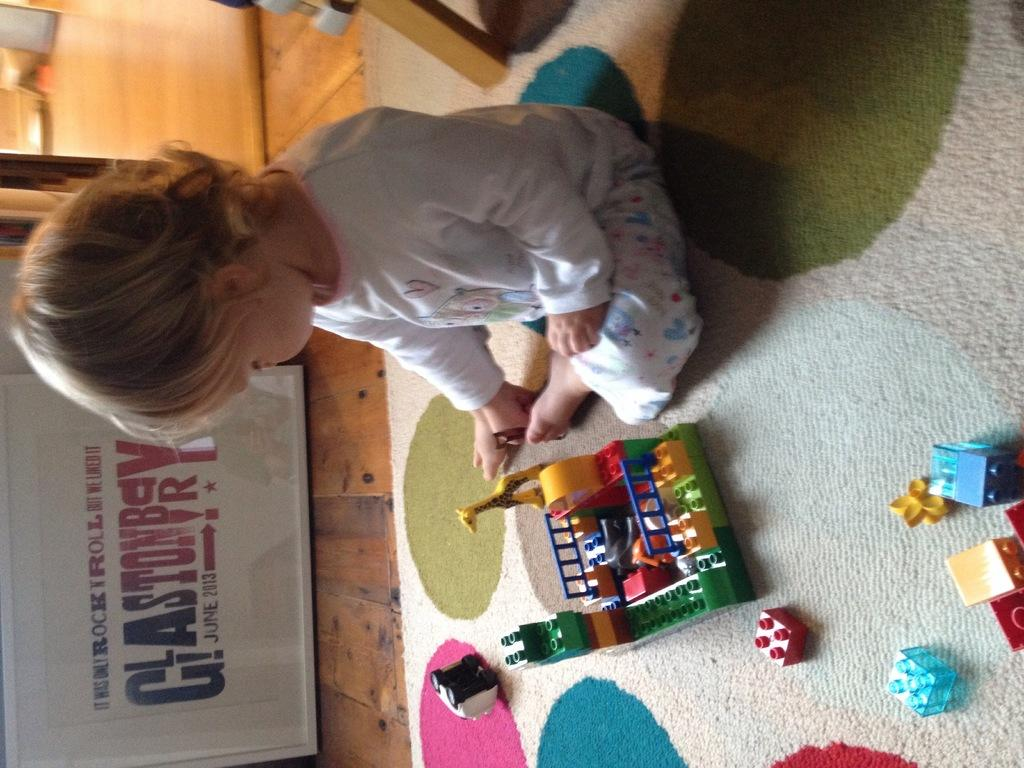What is the main subject of the image? There is a baby in the center of the image. What is the baby doing in the image? The baby is sitting and playing with legos. What can be seen in the background of the image? There is a floor and a wall visible in the background of the image. What type of fuel is the baby using to power their playtime in the image? There is no fuel present in the image, as the baby is playing with legos, which do not require fuel. 